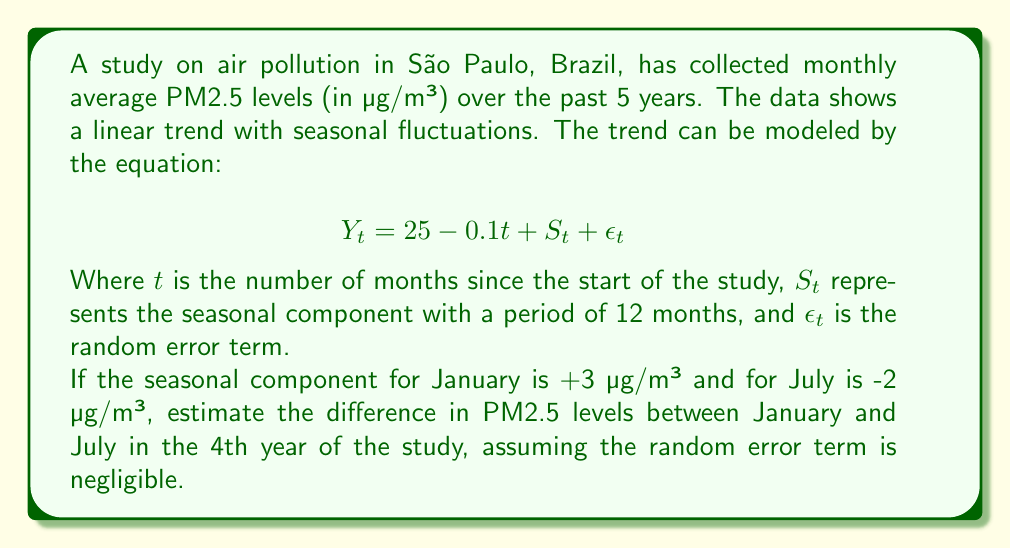Teach me how to tackle this problem. To solve this problem, we need to follow these steps:

1) Identify the months in question:
   - January of the 4th year is the 37th month (3 * 12 + 1)
   - July of the 4th year is the 43rd month (3 * 12 + 7)

2) Calculate the trend component for each month:
   For January (t = 37):
   $$25 - 0.1(37) = 25 - 3.7 = 21.3$$
   
   For July (t = 43):
   $$25 - 0.1(43) = 25 - 4.3 = 20.7$$

3) Add the seasonal component:
   For January: $S_t = +3$
   For July: $S_t = -2$

4) Calculate the final estimates:
   January: $21.3 + 3 = 24.3$ µg/m³
   July: $20.7 - 2 = 18.7$ µg/m³

5) Calculate the difference:
   $24.3 - 18.7 = 5.6$ µg/m³

The difference in PM2.5 levels between January and July in the 4th year is estimated to be 5.6 µg/m³, with January having the higher level.

This result shows that despite the overall decreasing trend in air pollution (as indicated by the negative coefficient of t), there are still significant seasonal variations, with January (summer in São Paulo) having higher pollution levels than July (winter).
Answer: 5.6 µg/m³ 